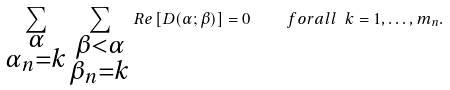<formula> <loc_0><loc_0><loc_500><loc_500>\sum _ { \substack { \alpha \\ \alpha _ { n } = k } } \sum _ { \substack { \beta < \alpha \\ \beta _ { n } = k } } R e \left [ D ( \alpha ; \beta ) \right ] = 0 \quad f o r a l l \ k = 1 , \dots , m _ { n } .</formula> 